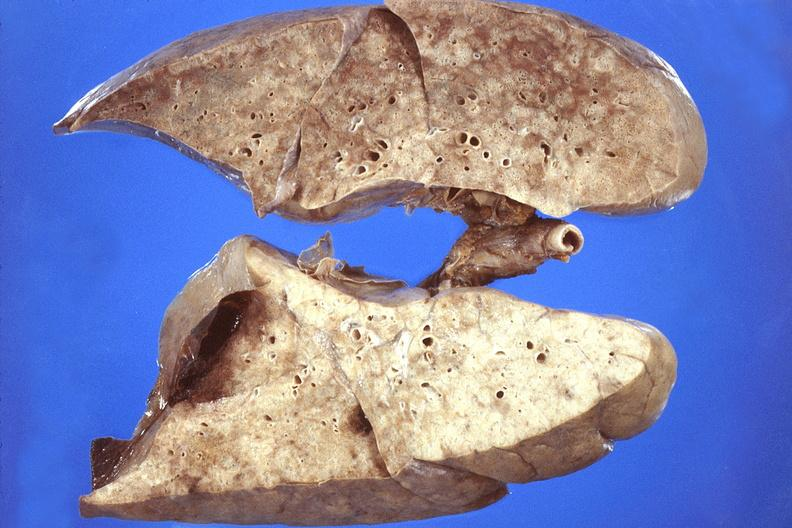what is present?
Answer the question using a single word or phrase. Respiratory 